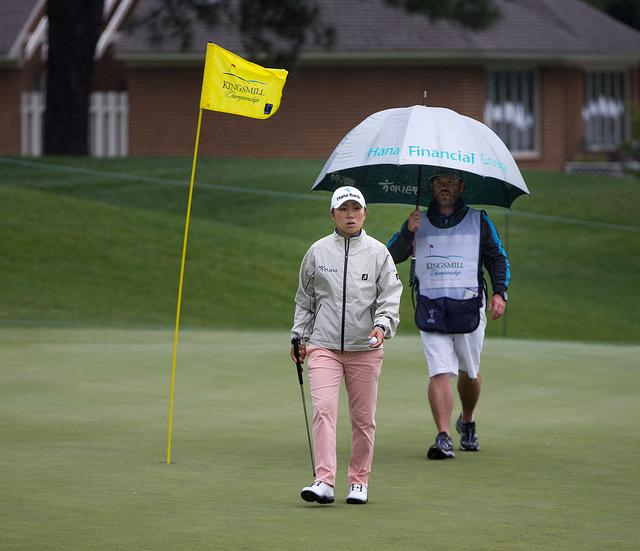What are they doing? golfing 